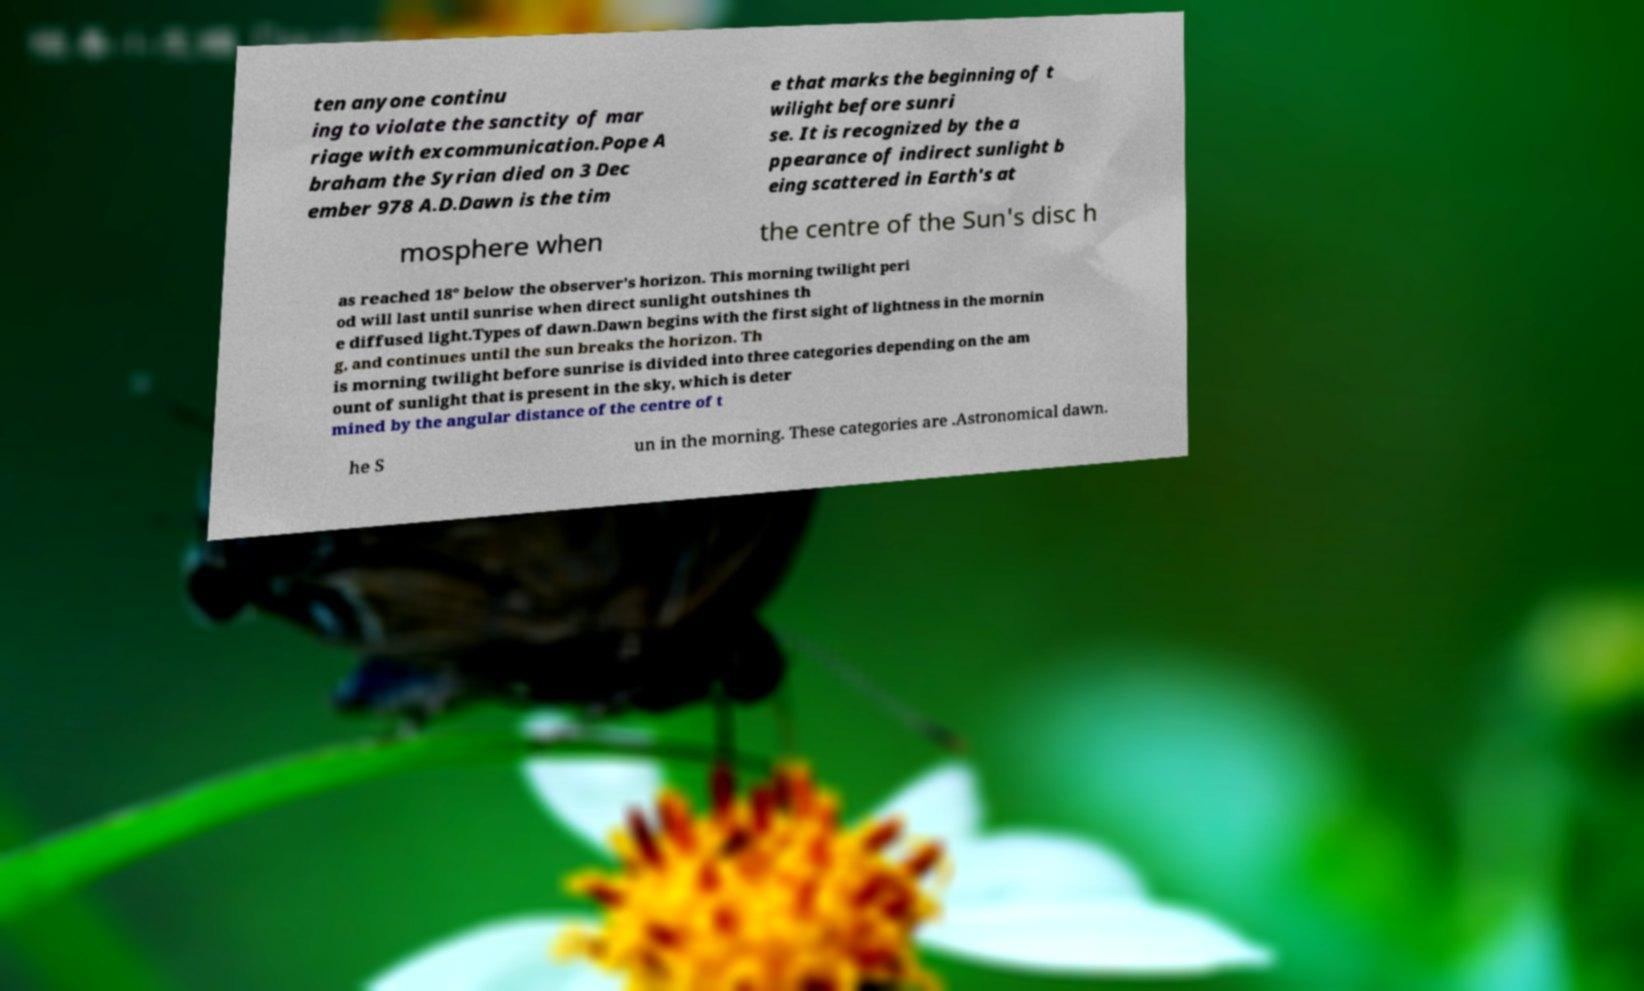For documentation purposes, I need the text within this image transcribed. Could you provide that? ten anyone continu ing to violate the sanctity of mar riage with excommunication.Pope A braham the Syrian died on 3 Dec ember 978 A.D.Dawn is the tim e that marks the beginning of t wilight before sunri se. It is recognized by the a ppearance of indirect sunlight b eing scattered in Earth's at mosphere when the centre of the Sun's disc h as reached 18° below the observer's horizon. This morning twilight peri od will last until sunrise when direct sunlight outshines th e diffused light.Types of dawn.Dawn begins with the first sight of lightness in the mornin g, and continues until the sun breaks the horizon. Th is morning twilight before sunrise is divided into three categories depending on the am ount of sunlight that is present in the sky, which is deter mined by the angular distance of the centre of t he S un in the morning. These categories are .Astronomical dawn. 